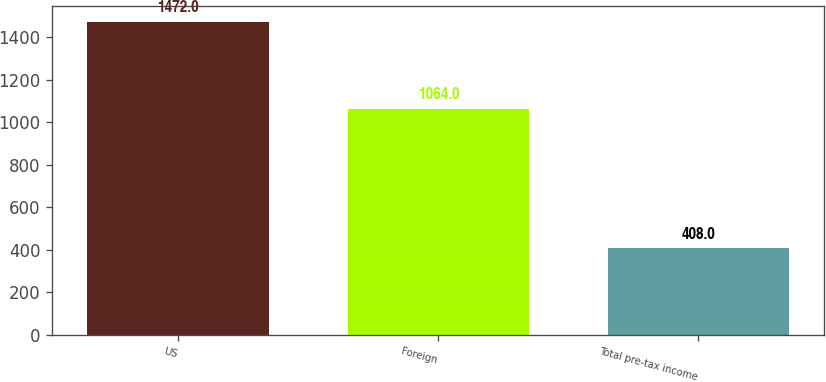<chart> <loc_0><loc_0><loc_500><loc_500><bar_chart><fcel>US<fcel>Foreign<fcel>Total pre-tax income<nl><fcel>1472<fcel>1064<fcel>408<nl></chart> 